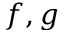<formula> <loc_0><loc_0><loc_500><loc_500>f , g</formula> 